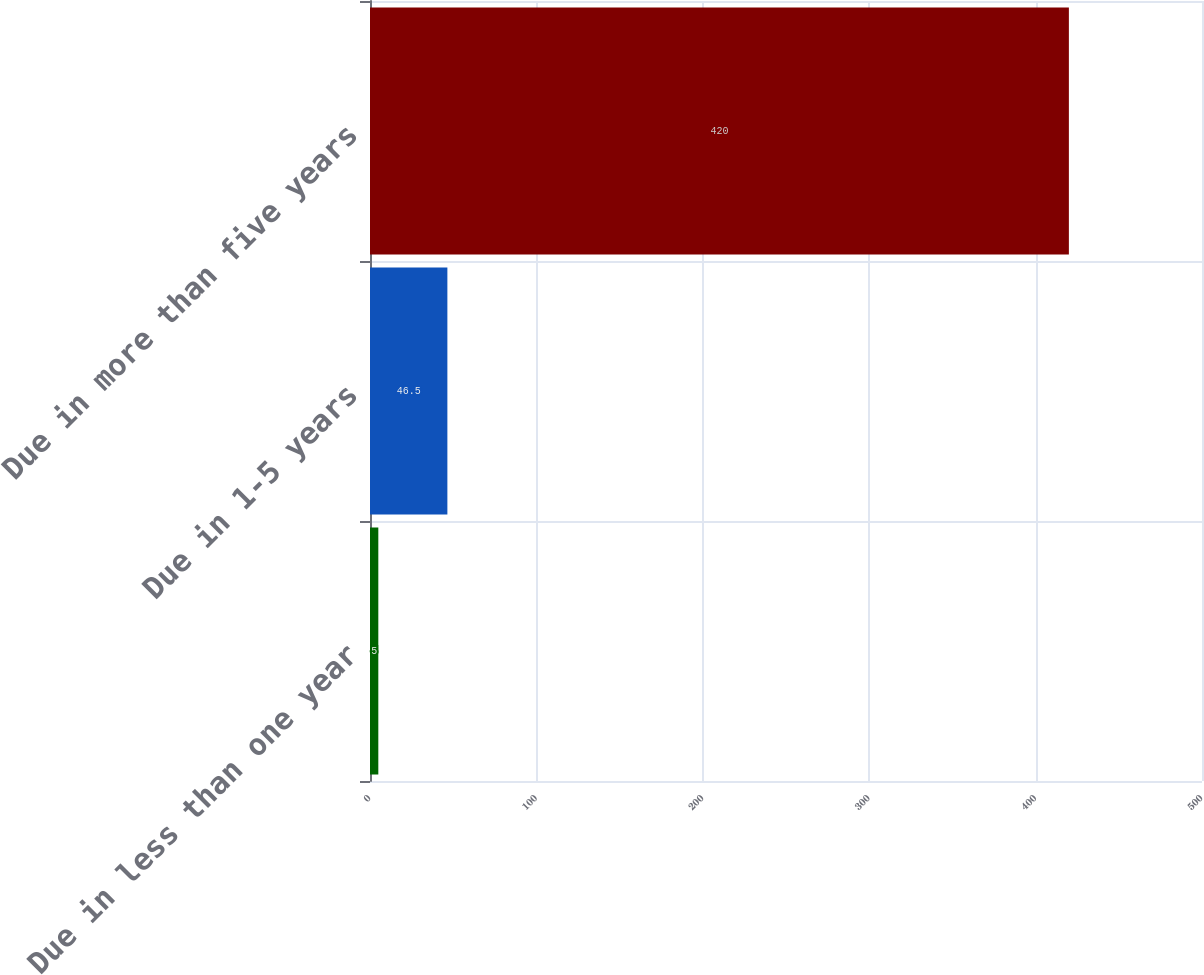<chart> <loc_0><loc_0><loc_500><loc_500><bar_chart><fcel>Due in less than one year<fcel>Due in 1-5 years<fcel>Due in more than five years<nl><fcel>5<fcel>46.5<fcel>420<nl></chart> 